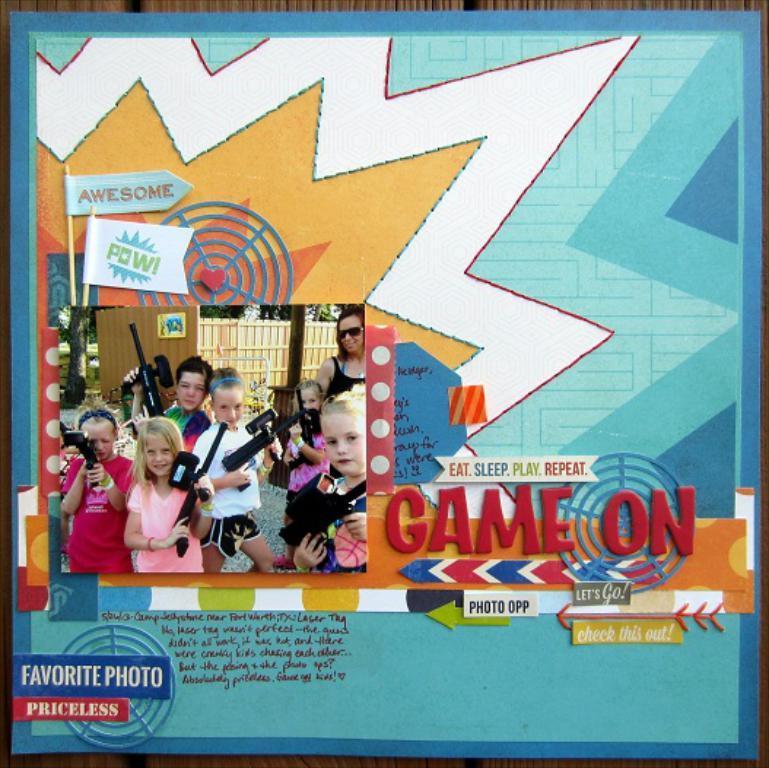Can you describe this image briefly? This looks like a poster. There are group of kids standing and holding weapons in their hands. I can see the letters in the image. This is the design on the poster. 